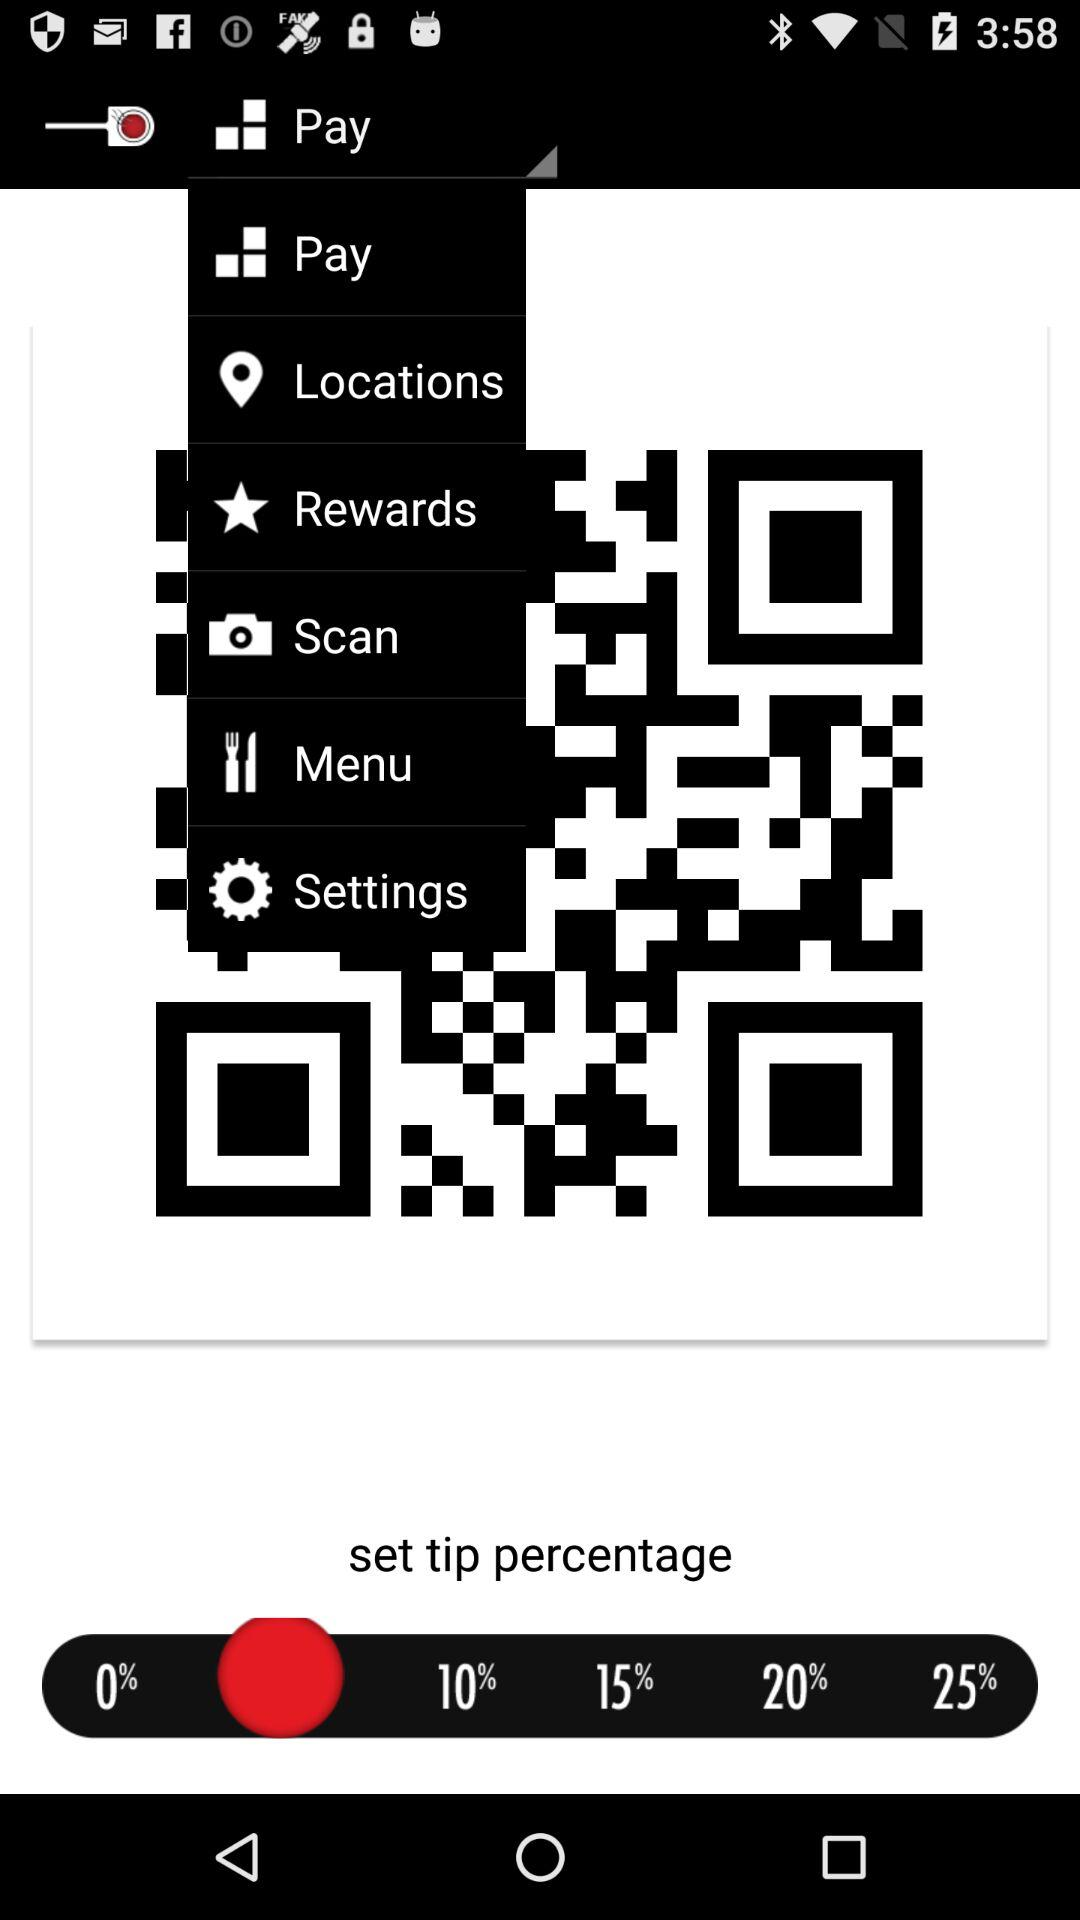What is the difference between the percentage of the tip for 10% and 20%?
Answer the question using a single word or phrase. 10 